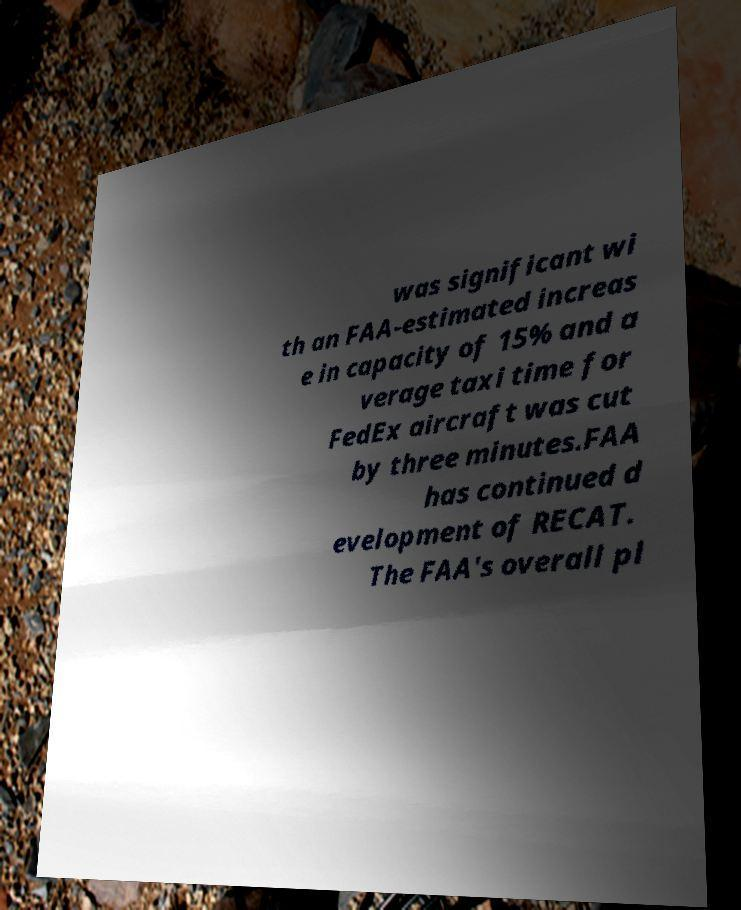Please read and relay the text visible in this image. What does it say? was significant wi th an FAA-estimated increas e in capacity of 15% and a verage taxi time for FedEx aircraft was cut by three minutes.FAA has continued d evelopment of RECAT. The FAA's overall pl 